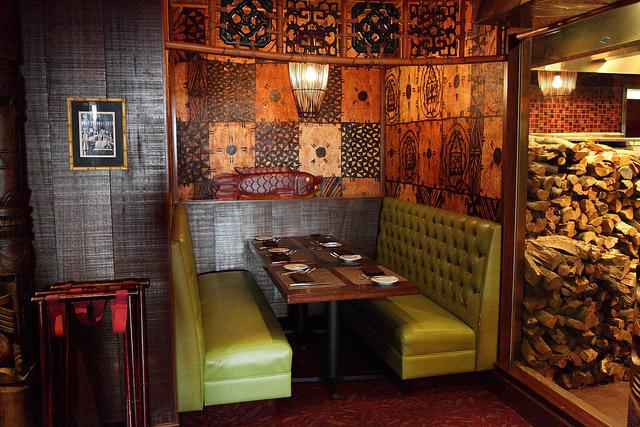What material is stockpiled?
Quick response, please. Wood. What kind of business is this picture likely to have been taken at?
Give a very brief answer. Restaurant. What is to the far right of the photo?
Answer briefly. Wood. 